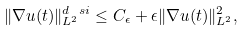Convert formula to latex. <formula><loc_0><loc_0><loc_500><loc_500>\| \nabla u ( t ) \| _ { L ^ { 2 } } ^ { d \ s i } \leq C _ { \epsilon } + \epsilon \| \nabla u ( t ) \| _ { L ^ { 2 } } ^ { 2 } ,</formula> 